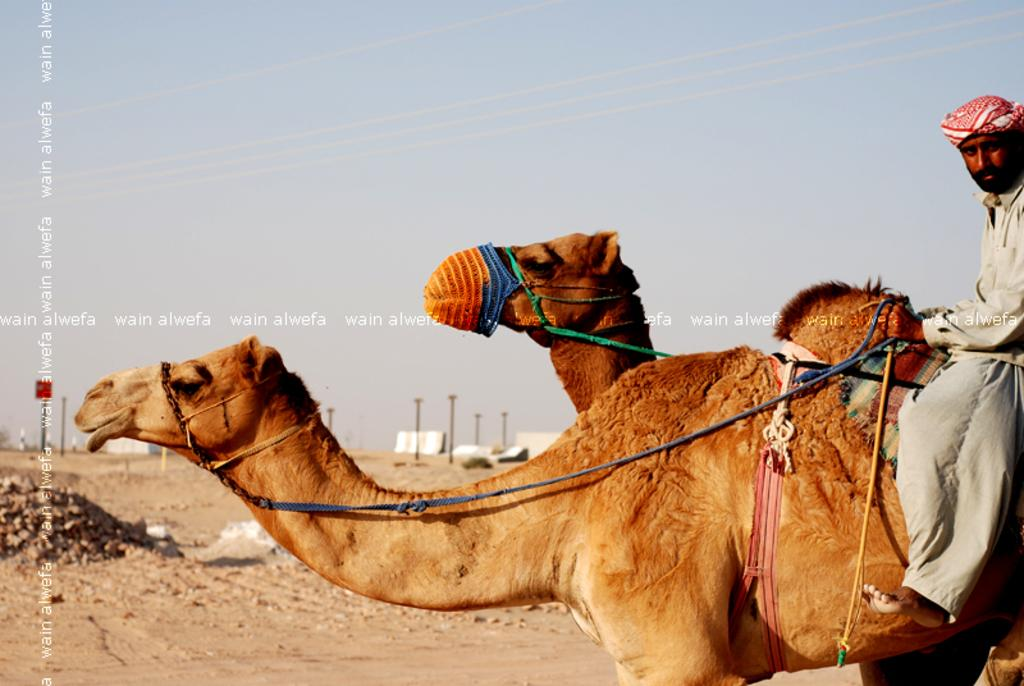What animals are in the foreground of the picture? There are two camels in the foreground of the picture. Who is present in the foreground of the picture besides the camels? There is a man in the foreground of the picture. What can be seen in the background of the picture? There are poles, tents, and sand in the background of the picture. What is the condition of the sky in the picture? The sky is clear and it is sunny in the picture. What type of haircut does the camel have in the image? Camels do not have haircuts, as they are animals and not humans. How many toes can be seen on the camel's feet in the image? Camels have two toes on each foot, but the image does not show the camels' feet in detail. 